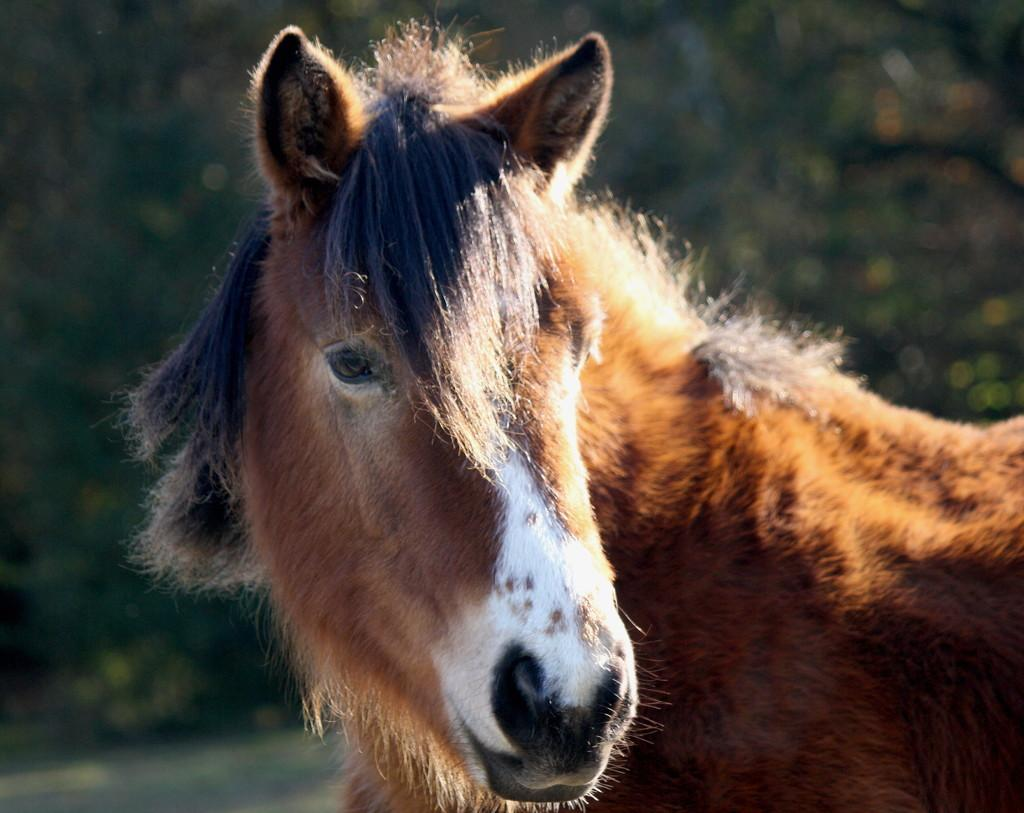What animal is present in the image? There is a horse in the image. Where is the hammer located in the image? There is no hammer present in the image. Is there a lake visible in the image? There is no lake present in the image. 